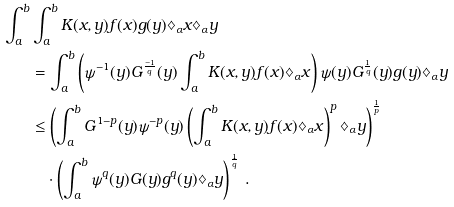Convert formula to latex. <formula><loc_0><loc_0><loc_500><loc_500>\int _ { a } ^ { b } & \int _ { a } ^ { b } K ( x , y ) f ( x ) g ( y ) \diamondsuit _ { \alpha } x \diamondsuit _ { \alpha } y \\ & = \int _ { a } ^ { b } \left ( \psi ^ { - 1 } ( y ) G ^ { \frac { - 1 } { q } } ( y ) \int _ { a } ^ { b } K ( x , y ) f ( x ) \diamondsuit _ { \alpha } x \right ) \psi ( y ) G ^ { \frac { 1 } { q } } ( y ) g ( y ) \diamondsuit _ { \alpha } y \\ & \leq \left ( \int _ { a } ^ { b } G ^ { 1 - p } ( y ) \psi ^ { - p } ( y ) \left ( \int _ { a } ^ { b } K ( x , y ) f ( x ) \diamondsuit _ { \alpha } x \right ) ^ { p } \diamondsuit _ { \alpha } y \right ) ^ { \frac { 1 } { p } } \\ & \quad \cdot \left ( \int _ { a } ^ { b } \psi ^ { q } ( y ) G ( y ) g ^ { q } ( y ) \diamondsuit _ { \alpha } y \right ) ^ { \frac { 1 } { q } } \, .</formula> 